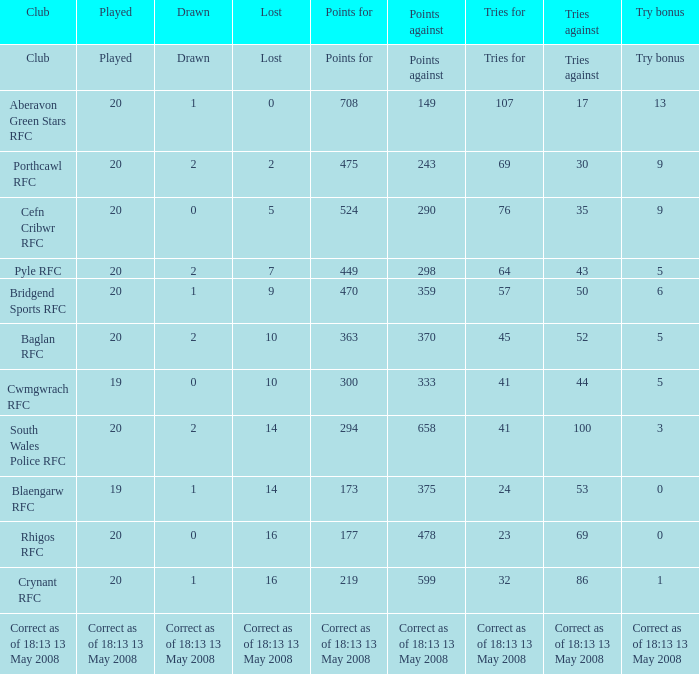How much is the loss when there are 5 try bonuses and 298 points against? 7.0. 